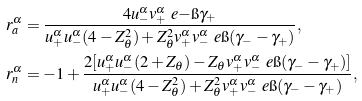Convert formula to latex. <formula><loc_0><loc_0><loc_500><loc_500>r _ { a } ^ { \alpha } & = \frac { 4 u _ { - } ^ { \alpha } v _ { + } ^ { \alpha } \ e { - \i \gamma _ { + } } } { u _ { + } ^ { \alpha } u _ { - } ^ { \alpha } ( 4 - Z _ { \theta } ^ { 2 } ) + Z _ { \theta } ^ { 2 } v _ { + } ^ { \alpha } v _ { - } ^ { \alpha } \ e { \i ( \gamma _ { - } - \gamma _ { + } ) } } , \\ r _ { n } ^ { \alpha } & = - 1 + \frac { 2 [ u _ { + } ^ { \alpha } u _ { - } ^ { \alpha } ( 2 + Z _ { \theta } ) - Z _ { \theta } v _ { + } ^ { \alpha } v _ { - } ^ { \alpha } \ e { \i ( \gamma _ { - } - \gamma _ { + } ) } ] } { u _ { + } ^ { \alpha } u _ { - } ^ { \alpha } ( 4 - Z _ { \theta } ^ { 2 } ) + Z _ { \theta } ^ { 2 } v _ { + } ^ { \alpha } v _ { - } ^ { \alpha } \ e { \i ( \gamma _ { - } - \gamma _ { + } ) } } ,</formula> 